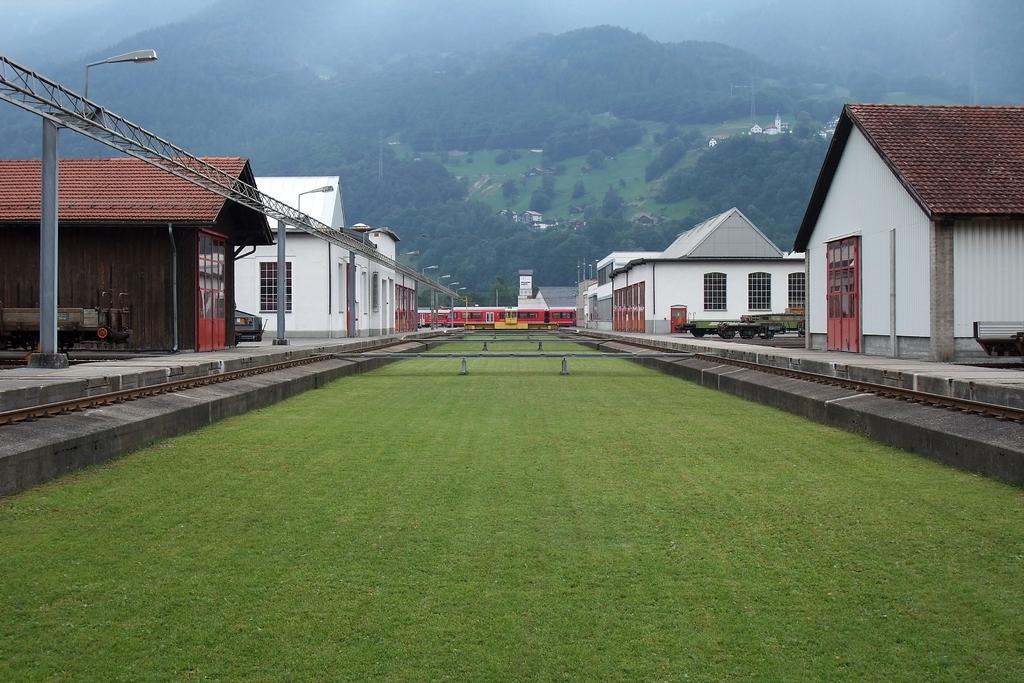Could you give a brief overview of what you see in this image? In this image I can see a train, houses, beam, poles, lights grass, trees and objects. 